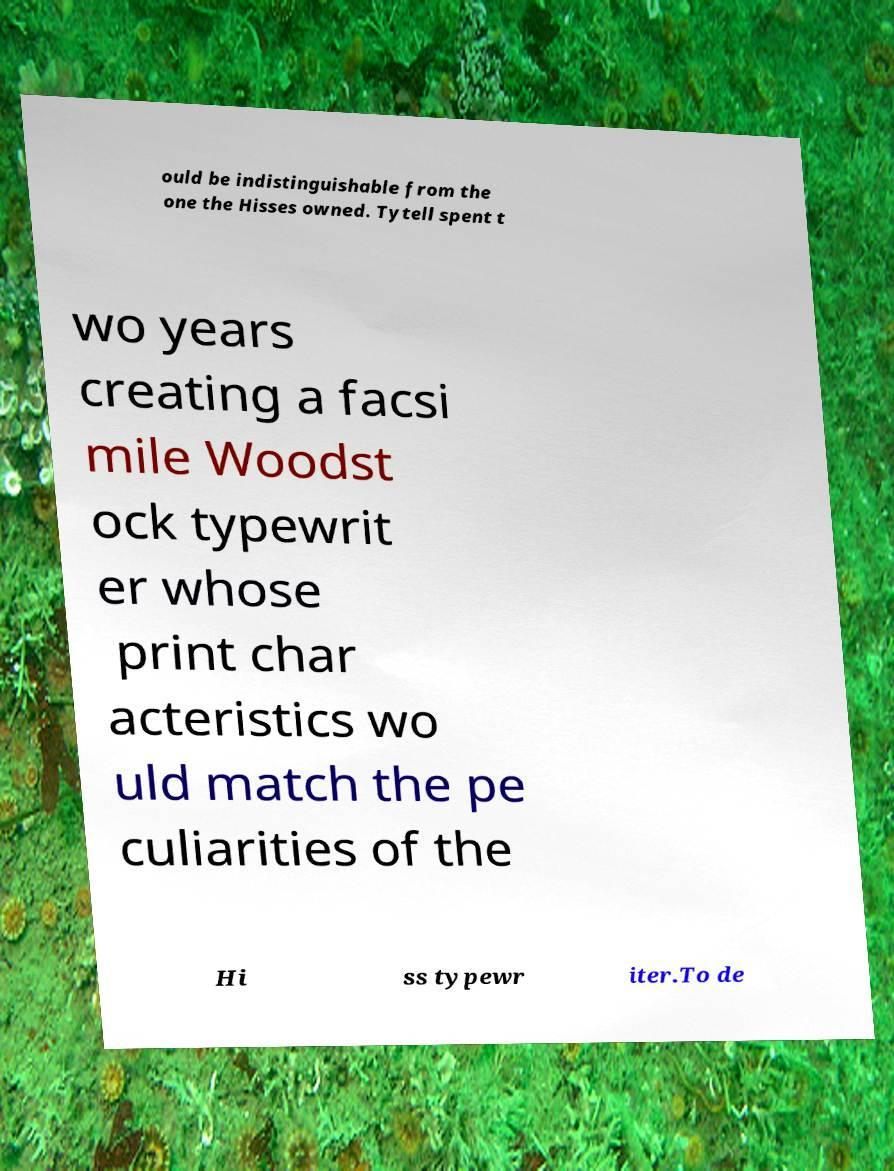Please identify and transcribe the text found in this image. ould be indistinguishable from the one the Hisses owned. Tytell spent t wo years creating a facsi mile Woodst ock typewrit er whose print char acteristics wo uld match the pe culiarities of the Hi ss typewr iter.To de 